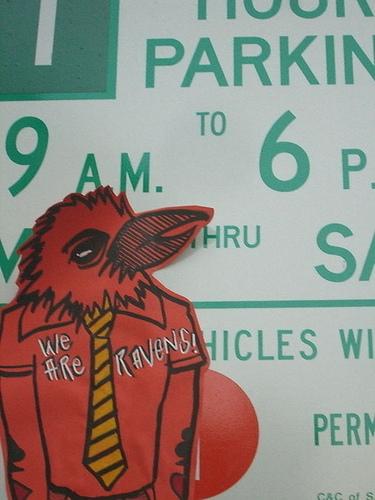What is written behind the bird?
Answer briefly. Vehicles. What does it say on the cartoon bird?
Give a very brief answer. We are ravens. What color is the bird?
Short answer required. Red. 